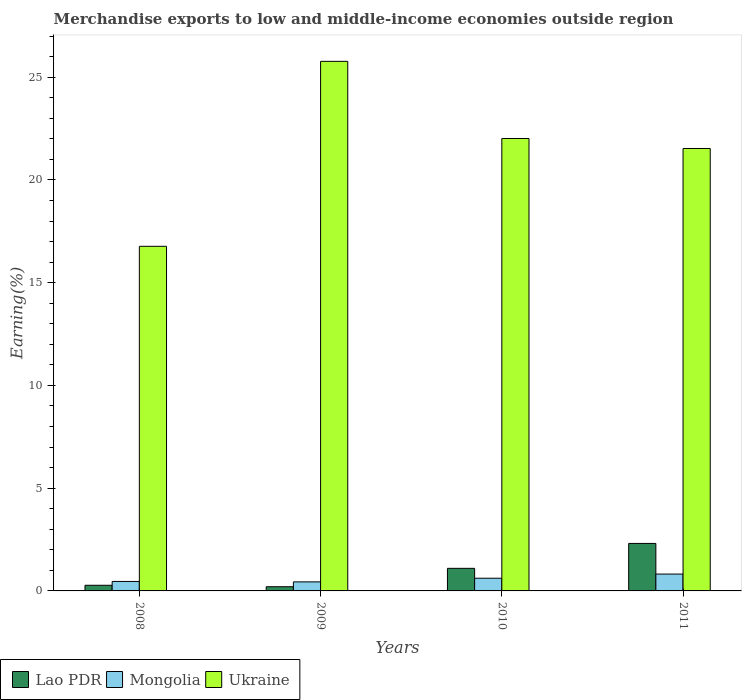How many groups of bars are there?
Give a very brief answer. 4. How many bars are there on the 1st tick from the left?
Your answer should be compact. 3. In how many cases, is the number of bars for a given year not equal to the number of legend labels?
Ensure brevity in your answer.  0. What is the percentage of amount earned from merchandise exports in Ukraine in 2008?
Make the answer very short. 16.77. Across all years, what is the maximum percentage of amount earned from merchandise exports in Lao PDR?
Keep it short and to the point. 2.31. Across all years, what is the minimum percentage of amount earned from merchandise exports in Mongolia?
Your response must be concise. 0.44. What is the total percentage of amount earned from merchandise exports in Lao PDR in the graph?
Give a very brief answer. 3.89. What is the difference between the percentage of amount earned from merchandise exports in Lao PDR in 2009 and that in 2010?
Your answer should be very brief. -0.9. What is the difference between the percentage of amount earned from merchandise exports in Lao PDR in 2008 and the percentage of amount earned from merchandise exports in Mongolia in 2010?
Ensure brevity in your answer.  -0.34. What is the average percentage of amount earned from merchandise exports in Mongolia per year?
Your answer should be very brief. 0.58. In the year 2010, what is the difference between the percentage of amount earned from merchandise exports in Mongolia and percentage of amount earned from merchandise exports in Lao PDR?
Provide a succinct answer. -0.48. In how many years, is the percentage of amount earned from merchandise exports in Mongolia greater than 22 %?
Offer a very short reply. 0. What is the ratio of the percentage of amount earned from merchandise exports in Mongolia in 2010 to that in 2011?
Give a very brief answer. 0.75. What is the difference between the highest and the second highest percentage of amount earned from merchandise exports in Mongolia?
Your response must be concise. 0.2. What is the difference between the highest and the lowest percentage of amount earned from merchandise exports in Mongolia?
Give a very brief answer. 0.38. In how many years, is the percentage of amount earned from merchandise exports in Ukraine greater than the average percentage of amount earned from merchandise exports in Ukraine taken over all years?
Provide a succinct answer. 3. What does the 3rd bar from the left in 2009 represents?
Provide a succinct answer. Ukraine. What does the 3rd bar from the right in 2009 represents?
Provide a succinct answer. Lao PDR. How many bars are there?
Give a very brief answer. 12. Are all the bars in the graph horizontal?
Provide a succinct answer. No. How many years are there in the graph?
Your answer should be very brief. 4. Are the values on the major ticks of Y-axis written in scientific E-notation?
Offer a terse response. No. Does the graph contain any zero values?
Provide a short and direct response. No. How many legend labels are there?
Offer a very short reply. 3. What is the title of the graph?
Provide a short and direct response. Merchandise exports to low and middle-income economies outside region. Does "Aruba" appear as one of the legend labels in the graph?
Make the answer very short. No. What is the label or title of the X-axis?
Provide a succinct answer. Years. What is the label or title of the Y-axis?
Ensure brevity in your answer.  Earning(%). What is the Earning(%) of Lao PDR in 2008?
Provide a succinct answer. 0.27. What is the Earning(%) in Mongolia in 2008?
Offer a terse response. 0.46. What is the Earning(%) in Ukraine in 2008?
Offer a very short reply. 16.77. What is the Earning(%) in Lao PDR in 2009?
Offer a very short reply. 0.2. What is the Earning(%) of Mongolia in 2009?
Give a very brief answer. 0.44. What is the Earning(%) of Ukraine in 2009?
Provide a short and direct response. 25.77. What is the Earning(%) in Lao PDR in 2010?
Ensure brevity in your answer.  1.1. What is the Earning(%) of Mongolia in 2010?
Provide a succinct answer. 0.62. What is the Earning(%) of Ukraine in 2010?
Your answer should be compact. 22.02. What is the Earning(%) of Lao PDR in 2011?
Offer a very short reply. 2.31. What is the Earning(%) of Mongolia in 2011?
Make the answer very short. 0.82. What is the Earning(%) in Ukraine in 2011?
Give a very brief answer. 21.53. Across all years, what is the maximum Earning(%) of Lao PDR?
Ensure brevity in your answer.  2.31. Across all years, what is the maximum Earning(%) of Mongolia?
Provide a succinct answer. 0.82. Across all years, what is the maximum Earning(%) of Ukraine?
Your response must be concise. 25.77. Across all years, what is the minimum Earning(%) of Lao PDR?
Provide a succinct answer. 0.2. Across all years, what is the minimum Earning(%) in Mongolia?
Offer a very short reply. 0.44. Across all years, what is the minimum Earning(%) of Ukraine?
Provide a short and direct response. 16.77. What is the total Earning(%) in Lao PDR in the graph?
Your answer should be very brief. 3.89. What is the total Earning(%) in Mongolia in the graph?
Offer a terse response. 2.34. What is the total Earning(%) of Ukraine in the graph?
Ensure brevity in your answer.  86.08. What is the difference between the Earning(%) in Lao PDR in 2008 and that in 2009?
Provide a short and direct response. 0.07. What is the difference between the Earning(%) in Mongolia in 2008 and that in 2009?
Ensure brevity in your answer.  0.02. What is the difference between the Earning(%) in Ukraine in 2008 and that in 2009?
Offer a very short reply. -9. What is the difference between the Earning(%) of Lao PDR in 2008 and that in 2010?
Give a very brief answer. -0.82. What is the difference between the Earning(%) in Mongolia in 2008 and that in 2010?
Your answer should be very brief. -0.16. What is the difference between the Earning(%) in Ukraine in 2008 and that in 2010?
Your answer should be compact. -5.25. What is the difference between the Earning(%) in Lao PDR in 2008 and that in 2011?
Give a very brief answer. -2.04. What is the difference between the Earning(%) of Mongolia in 2008 and that in 2011?
Your answer should be very brief. -0.36. What is the difference between the Earning(%) of Ukraine in 2008 and that in 2011?
Provide a succinct answer. -4.76. What is the difference between the Earning(%) in Lao PDR in 2009 and that in 2010?
Offer a terse response. -0.9. What is the difference between the Earning(%) of Mongolia in 2009 and that in 2010?
Your answer should be very brief. -0.18. What is the difference between the Earning(%) in Ukraine in 2009 and that in 2010?
Your answer should be compact. 3.75. What is the difference between the Earning(%) of Lao PDR in 2009 and that in 2011?
Give a very brief answer. -2.11. What is the difference between the Earning(%) in Mongolia in 2009 and that in 2011?
Keep it short and to the point. -0.38. What is the difference between the Earning(%) in Ukraine in 2009 and that in 2011?
Ensure brevity in your answer.  4.24. What is the difference between the Earning(%) of Lao PDR in 2010 and that in 2011?
Make the answer very short. -1.21. What is the difference between the Earning(%) in Mongolia in 2010 and that in 2011?
Make the answer very short. -0.2. What is the difference between the Earning(%) of Ukraine in 2010 and that in 2011?
Offer a very short reply. 0.49. What is the difference between the Earning(%) of Lao PDR in 2008 and the Earning(%) of Mongolia in 2009?
Your response must be concise. -0.17. What is the difference between the Earning(%) in Lao PDR in 2008 and the Earning(%) in Ukraine in 2009?
Offer a terse response. -25.49. What is the difference between the Earning(%) of Mongolia in 2008 and the Earning(%) of Ukraine in 2009?
Your answer should be very brief. -25.31. What is the difference between the Earning(%) in Lao PDR in 2008 and the Earning(%) in Mongolia in 2010?
Make the answer very short. -0.34. What is the difference between the Earning(%) in Lao PDR in 2008 and the Earning(%) in Ukraine in 2010?
Ensure brevity in your answer.  -21.74. What is the difference between the Earning(%) in Mongolia in 2008 and the Earning(%) in Ukraine in 2010?
Your answer should be compact. -21.55. What is the difference between the Earning(%) in Lao PDR in 2008 and the Earning(%) in Mongolia in 2011?
Your answer should be compact. -0.55. What is the difference between the Earning(%) of Lao PDR in 2008 and the Earning(%) of Ukraine in 2011?
Keep it short and to the point. -21.25. What is the difference between the Earning(%) in Mongolia in 2008 and the Earning(%) in Ukraine in 2011?
Your answer should be very brief. -21.07. What is the difference between the Earning(%) of Lao PDR in 2009 and the Earning(%) of Mongolia in 2010?
Offer a very short reply. -0.41. What is the difference between the Earning(%) in Lao PDR in 2009 and the Earning(%) in Ukraine in 2010?
Ensure brevity in your answer.  -21.81. What is the difference between the Earning(%) in Mongolia in 2009 and the Earning(%) in Ukraine in 2010?
Give a very brief answer. -21.58. What is the difference between the Earning(%) in Lao PDR in 2009 and the Earning(%) in Mongolia in 2011?
Keep it short and to the point. -0.62. What is the difference between the Earning(%) of Lao PDR in 2009 and the Earning(%) of Ukraine in 2011?
Provide a short and direct response. -21.32. What is the difference between the Earning(%) of Mongolia in 2009 and the Earning(%) of Ukraine in 2011?
Your response must be concise. -21.09. What is the difference between the Earning(%) in Lao PDR in 2010 and the Earning(%) in Mongolia in 2011?
Your response must be concise. 0.28. What is the difference between the Earning(%) of Lao PDR in 2010 and the Earning(%) of Ukraine in 2011?
Provide a succinct answer. -20.43. What is the difference between the Earning(%) of Mongolia in 2010 and the Earning(%) of Ukraine in 2011?
Provide a short and direct response. -20.91. What is the average Earning(%) in Lao PDR per year?
Your answer should be very brief. 0.97. What is the average Earning(%) in Mongolia per year?
Give a very brief answer. 0.58. What is the average Earning(%) of Ukraine per year?
Give a very brief answer. 21.52. In the year 2008, what is the difference between the Earning(%) of Lao PDR and Earning(%) of Mongolia?
Provide a short and direct response. -0.19. In the year 2008, what is the difference between the Earning(%) of Lao PDR and Earning(%) of Ukraine?
Your response must be concise. -16.49. In the year 2008, what is the difference between the Earning(%) of Mongolia and Earning(%) of Ukraine?
Your response must be concise. -16.31. In the year 2009, what is the difference between the Earning(%) in Lao PDR and Earning(%) in Mongolia?
Make the answer very short. -0.24. In the year 2009, what is the difference between the Earning(%) of Lao PDR and Earning(%) of Ukraine?
Keep it short and to the point. -25.57. In the year 2009, what is the difference between the Earning(%) in Mongolia and Earning(%) in Ukraine?
Offer a terse response. -25.33. In the year 2010, what is the difference between the Earning(%) of Lao PDR and Earning(%) of Mongolia?
Provide a short and direct response. 0.48. In the year 2010, what is the difference between the Earning(%) of Lao PDR and Earning(%) of Ukraine?
Your response must be concise. -20.92. In the year 2010, what is the difference between the Earning(%) in Mongolia and Earning(%) in Ukraine?
Keep it short and to the point. -21.4. In the year 2011, what is the difference between the Earning(%) in Lao PDR and Earning(%) in Mongolia?
Offer a terse response. 1.49. In the year 2011, what is the difference between the Earning(%) of Lao PDR and Earning(%) of Ukraine?
Offer a terse response. -19.22. In the year 2011, what is the difference between the Earning(%) of Mongolia and Earning(%) of Ukraine?
Make the answer very short. -20.71. What is the ratio of the Earning(%) in Lao PDR in 2008 to that in 2009?
Offer a terse response. 1.35. What is the ratio of the Earning(%) in Mongolia in 2008 to that in 2009?
Make the answer very short. 1.05. What is the ratio of the Earning(%) in Ukraine in 2008 to that in 2009?
Provide a succinct answer. 0.65. What is the ratio of the Earning(%) of Lao PDR in 2008 to that in 2010?
Your answer should be compact. 0.25. What is the ratio of the Earning(%) of Mongolia in 2008 to that in 2010?
Ensure brevity in your answer.  0.75. What is the ratio of the Earning(%) of Ukraine in 2008 to that in 2010?
Your response must be concise. 0.76. What is the ratio of the Earning(%) of Lao PDR in 2008 to that in 2011?
Provide a short and direct response. 0.12. What is the ratio of the Earning(%) in Mongolia in 2008 to that in 2011?
Your answer should be very brief. 0.56. What is the ratio of the Earning(%) in Ukraine in 2008 to that in 2011?
Ensure brevity in your answer.  0.78. What is the ratio of the Earning(%) of Lao PDR in 2009 to that in 2010?
Make the answer very short. 0.19. What is the ratio of the Earning(%) in Mongolia in 2009 to that in 2010?
Your answer should be very brief. 0.71. What is the ratio of the Earning(%) in Ukraine in 2009 to that in 2010?
Your response must be concise. 1.17. What is the ratio of the Earning(%) in Lao PDR in 2009 to that in 2011?
Make the answer very short. 0.09. What is the ratio of the Earning(%) in Mongolia in 2009 to that in 2011?
Make the answer very short. 0.54. What is the ratio of the Earning(%) of Ukraine in 2009 to that in 2011?
Provide a short and direct response. 1.2. What is the ratio of the Earning(%) in Lao PDR in 2010 to that in 2011?
Provide a short and direct response. 0.48. What is the ratio of the Earning(%) in Mongolia in 2010 to that in 2011?
Keep it short and to the point. 0.75. What is the ratio of the Earning(%) in Ukraine in 2010 to that in 2011?
Provide a short and direct response. 1.02. What is the difference between the highest and the second highest Earning(%) in Lao PDR?
Your answer should be compact. 1.21. What is the difference between the highest and the second highest Earning(%) in Mongolia?
Your response must be concise. 0.2. What is the difference between the highest and the second highest Earning(%) of Ukraine?
Provide a short and direct response. 3.75. What is the difference between the highest and the lowest Earning(%) in Lao PDR?
Offer a terse response. 2.11. What is the difference between the highest and the lowest Earning(%) of Mongolia?
Offer a terse response. 0.38. What is the difference between the highest and the lowest Earning(%) of Ukraine?
Keep it short and to the point. 9. 